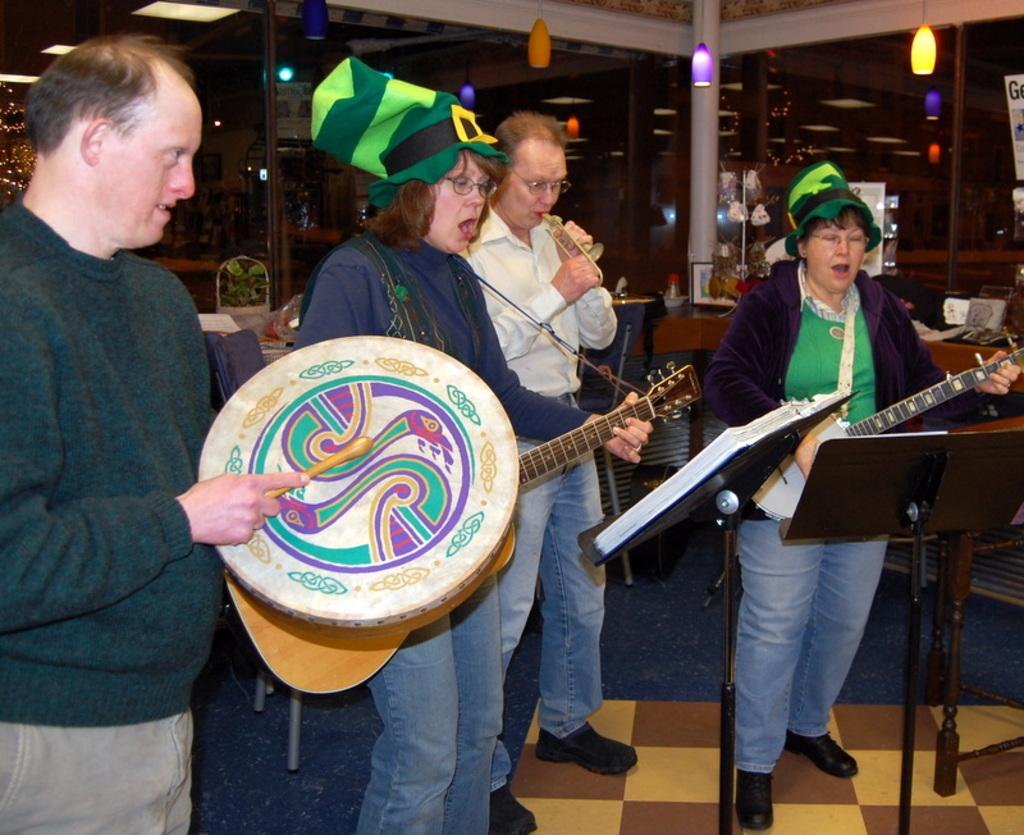How many people are present in the image? There are 4 people in the image. What are the people doing in the image? The people are standing and playing musical instruments. What can be seen on the right side of the image? There are notes on the right side of the image. What is visible at the top of the image? There are lights at the top of the image. What type of range can be seen in the image? There is no range present in the image; it features people playing musical instruments. How many thumbs does the man in the image have? There is no man mentioned in the image, and therefore no specific number of thumbs can be determined. 